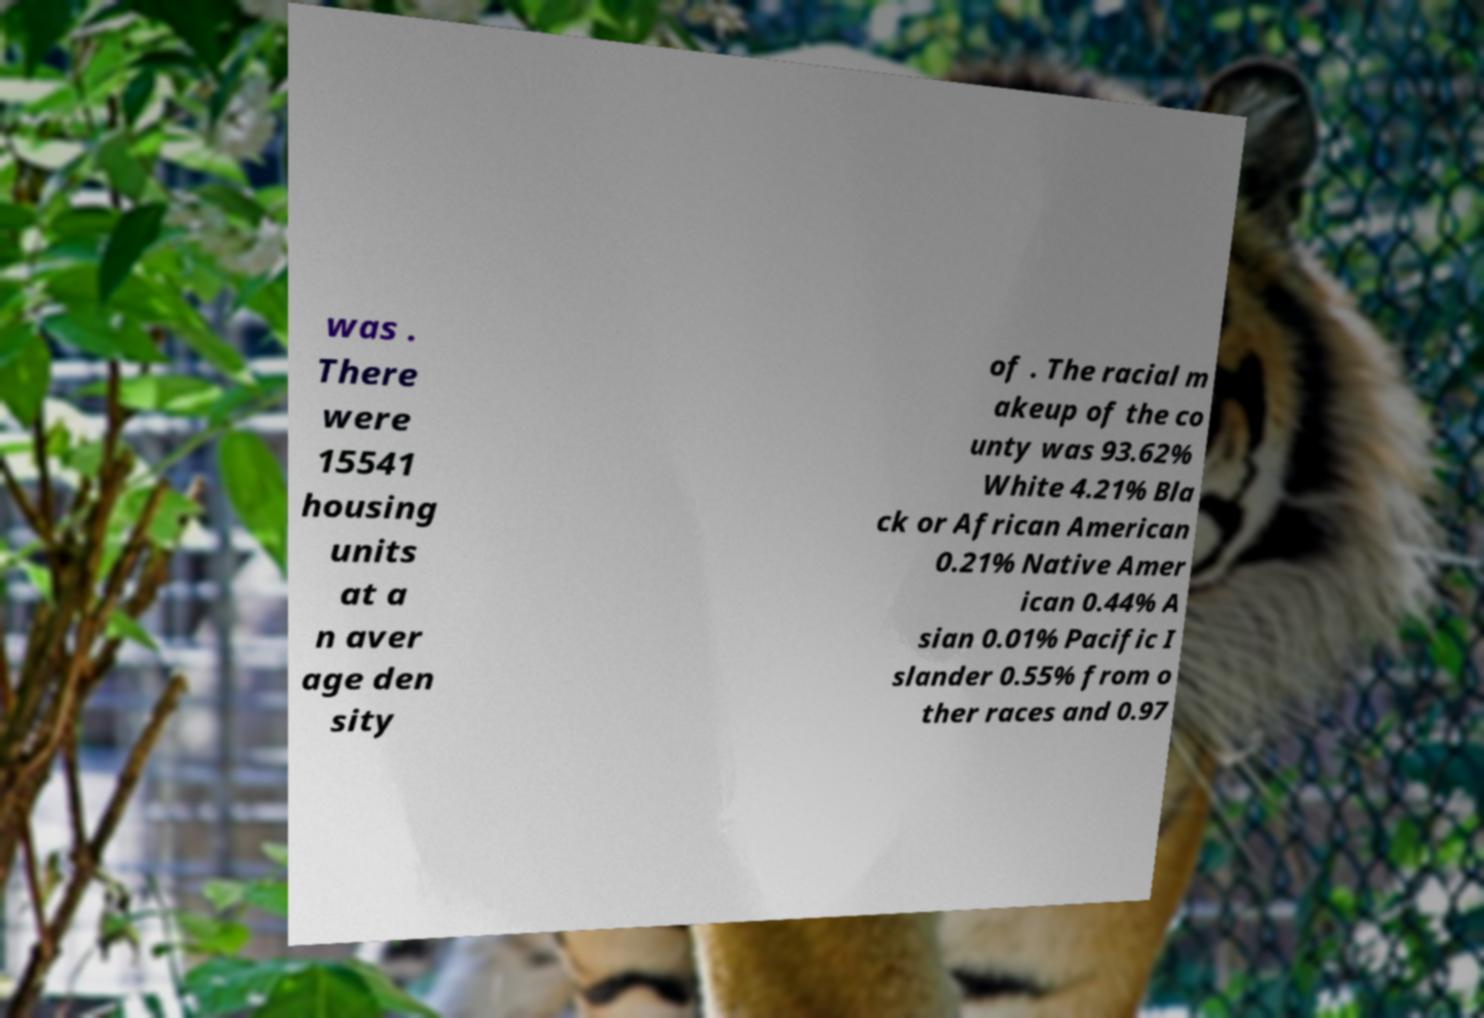Please identify and transcribe the text found in this image. was . There were 15541 housing units at a n aver age den sity of . The racial m akeup of the co unty was 93.62% White 4.21% Bla ck or African American 0.21% Native Amer ican 0.44% A sian 0.01% Pacific I slander 0.55% from o ther races and 0.97 